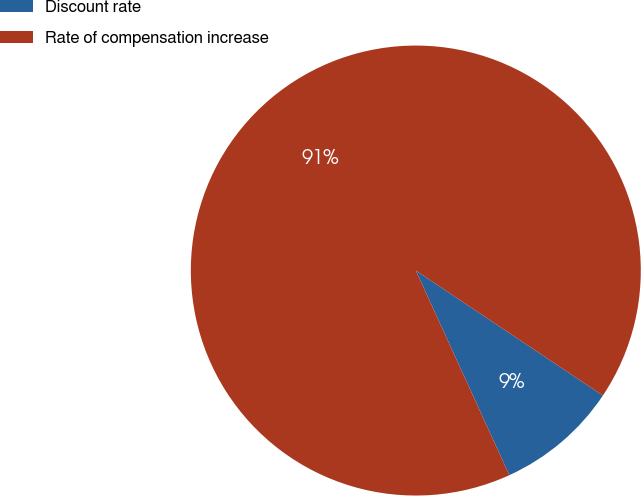<chart> <loc_0><loc_0><loc_500><loc_500><pie_chart><fcel>Discount rate<fcel>Rate of compensation increase<nl><fcel>8.8%<fcel>91.2%<nl></chart> 